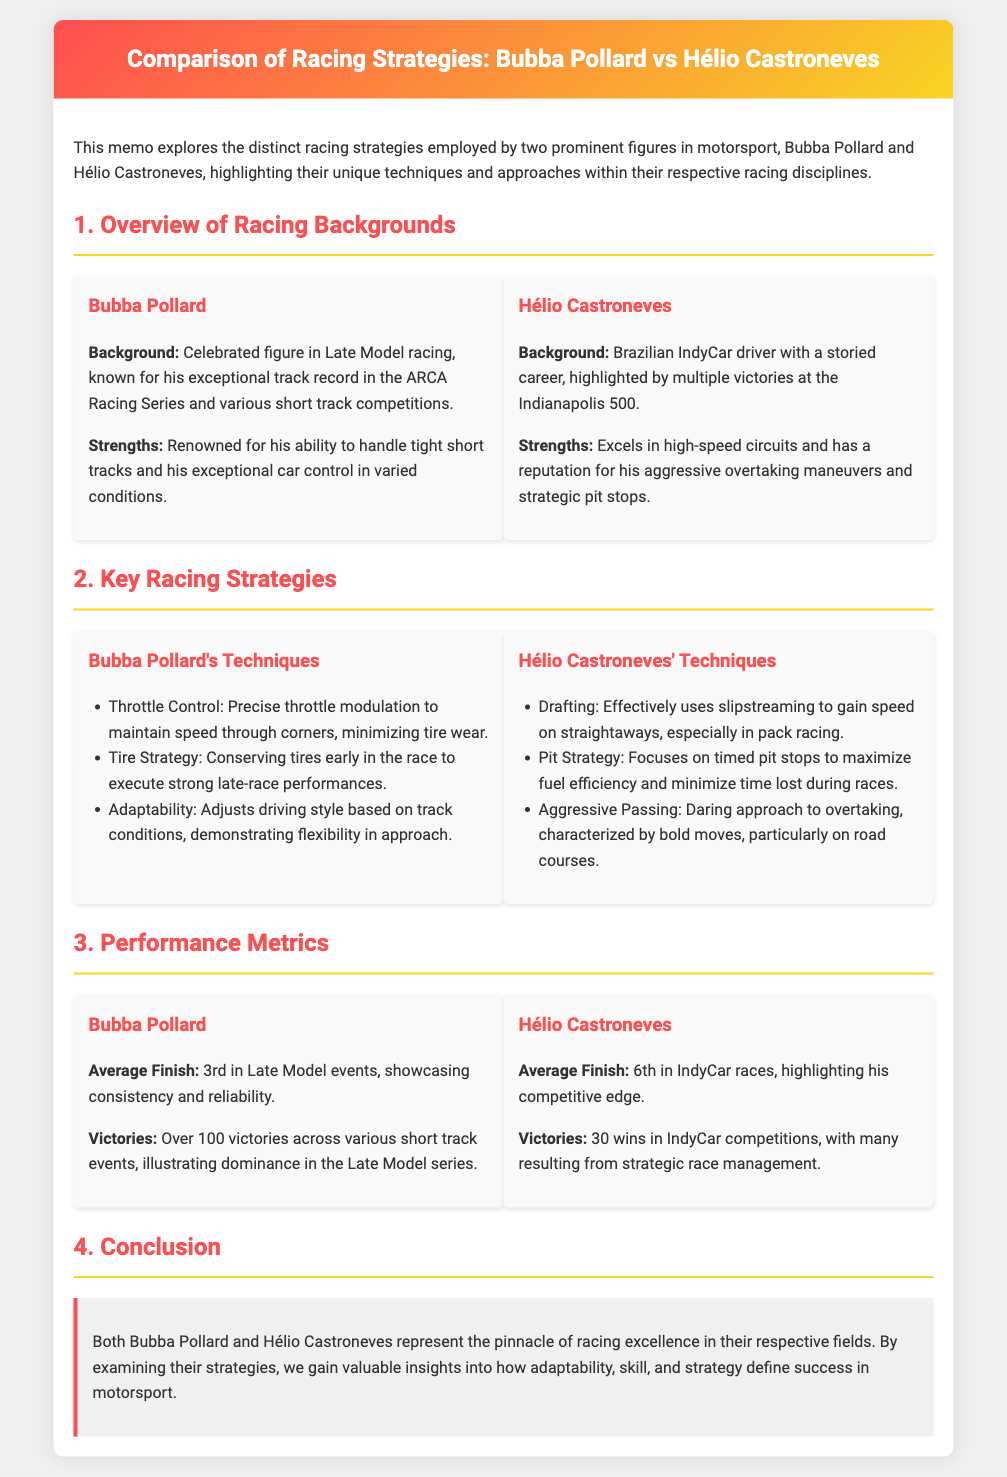What is Bubba Pollard known for? Bubba Pollard is celebrated for his exceptional track record in the ARCA Racing Series and various short track competitions.
Answer: exceptional track record in the ARCA Racing Series and various short track competitions How many victories does Hélio Castroneves have in IndyCar competitions? Hélio Castroneves has 30 wins in IndyCar competitions.
Answer: 30 wins Which racing series does Bubba Pollard primarily compete in? Bubba Pollard primarily competes in Late Model racing.
Answer: Late Model racing What average finish does Bubba Pollard achieve in Late Model events? Bubba Pollard has an average finish of 3rd in Late Model events.
Answer: 3rd What key technique does Hélio Castroneves use during pack racing? Hélio Castroneves effectively uses slipstreaming during pack racing.
Answer: slipstreaming Why is Bubba Pollard's tire strategy significant? Bubba Pollard's tire strategy is significant because he conserves tires early in the race for strong late-race performances.
Answer: conserves tires early for strong late-race performances What aspect of racing does Hélio Castroneves excel in? Hélio Castroneves excels in high-speed circuits.
Answer: high-speed circuits What does the conclusion suggest about the strategies employed by both racers? The conclusion suggests that adaptability, skill, and strategy define success in motorsport.
Answer: adaptability, skill, and strategy define success in motorsport 